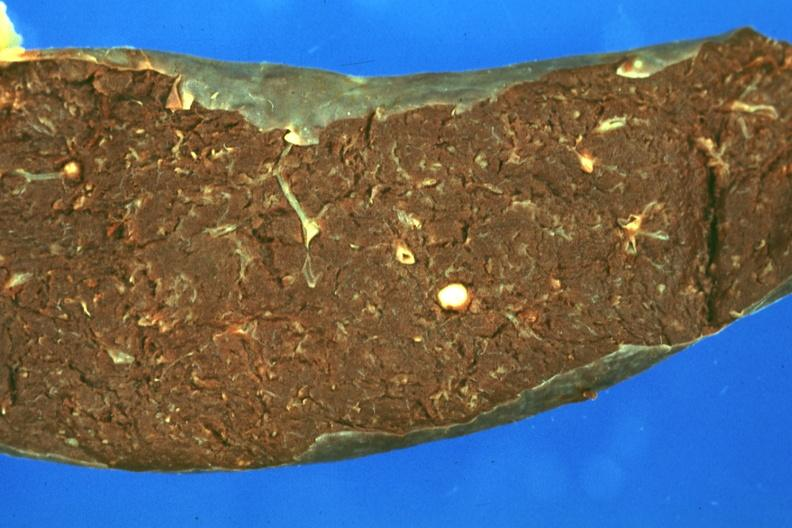s opened muscle present?
Answer the question using a single word or phrase. No 